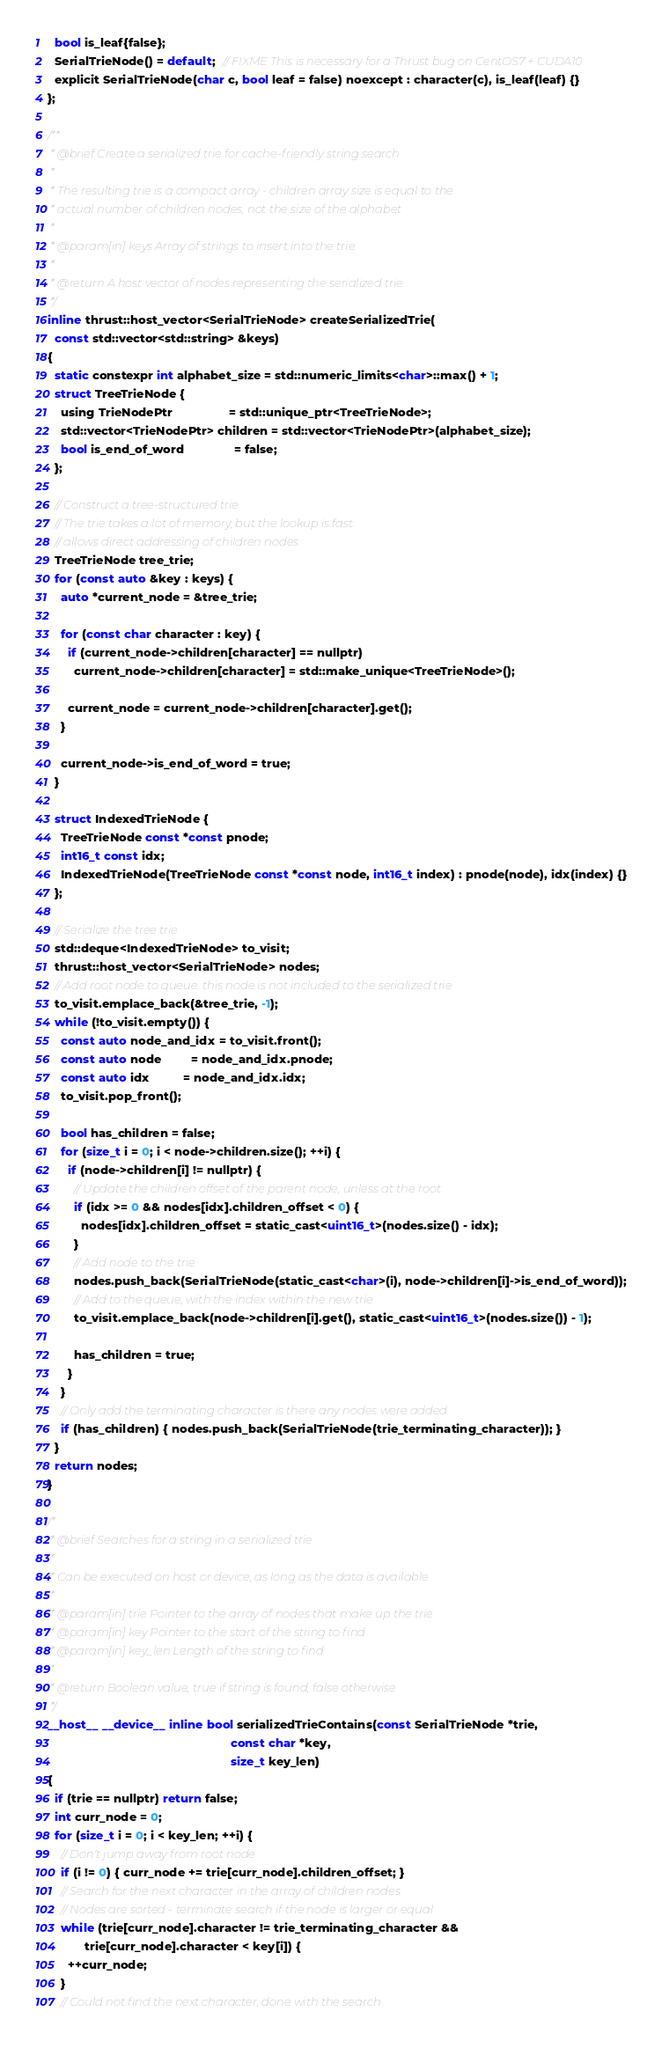<code> <loc_0><loc_0><loc_500><loc_500><_Cuda_>  bool is_leaf{false};
  SerialTrieNode() = default;  // FIXME This is necessary for a Thrust bug on CentOS7 + CUDA10
  explicit SerialTrieNode(char c, bool leaf = false) noexcept : character(c), is_leaf(leaf) {}
};

/**
 * @brief Create a serialized trie for cache-friendly string search
 *
 * The resulting trie is a compact array - children array size is equal to the
 * actual number of children nodes, not the size of the alphabet
 *
 * @param[in] keys Array of strings to insert into the trie
 *
 * @return A host vector of nodes representing the serialized trie
 */
inline thrust::host_vector<SerialTrieNode> createSerializedTrie(
  const std::vector<std::string> &keys)
{
  static constexpr int alphabet_size = std::numeric_limits<char>::max() + 1;
  struct TreeTrieNode {
    using TrieNodePtr                 = std::unique_ptr<TreeTrieNode>;
    std::vector<TrieNodePtr> children = std::vector<TrieNodePtr>(alphabet_size);
    bool is_end_of_word               = false;
  };

  // Construct a tree-structured trie
  // The trie takes a lot of memory, but the lookup is fast:
  // allows direct addressing of children nodes
  TreeTrieNode tree_trie;
  for (const auto &key : keys) {
    auto *current_node = &tree_trie;

    for (const char character : key) {
      if (current_node->children[character] == nullptr)
        current_node->children[character] = std::make_unique<TreeTrieNode>();

      current_node = current_node->children[character].get();
    }

    current_node->is_end_of_word = true;
  }

  struct IndexedTrieNode {
    TreeTrieNode const *const pnode;
    int16_t const idx;
    IndexedTrieNode(TreeTrieNode const *const node, int16_t index) : pnode(node), idx(index) {}
  };

  // Serialize the tree trie
  std::deque<IndexedTrieNode> to_visit;
  thrust::host_vector<SerialTrieNode> nodes;
  // Add root node to queue. this node is not included to the serialized trie
  to_visit.emplace_back(&tree_trie, -1);
  while (!to_visit.empty()) {
    const auto node_and_idx = to_visit.front();
    const auto node         = node_and_idx.pnode;
    const auto idx          = node_and_idx.idx;
    to_visit.pop_front();

    bool has_children = false;
    for (size_t i = 0; i < node->children.size(); ++i) {
      if (node->children[i] != nullptr) {
        // Update the children offset of the parent node, unless at the root
        if (idx >= 0 && nodes[idx].children_offset < 0) {
          nodes[idx].children_offset = static_cast<uint16_t>(nodes.size() - idx);
        }
        // Add node to the trie
        nodes.push_back(SerialTrieNode(static_cast<char>(i), node->children[i]->is_end_of_word));
        // Add to the queue, with the index within the new trie
        to_visit.emplace_back(node->children[i].get(), static_cast<uint16_t>(nodes.size()) - 1);

        has_children = true;
      }
    }
    // Only add the terminating character is there any nodes were added
    if (has_children) { nodes.push_back(SerialTrieNode(trie_terminating_character)); }
  }
  return nodes;
}

/*
 * @brief Searches for a string in a serialized trie
 *
 * Can be executed on host or device, as long as the data is available
 *
 * @param[in] trie Pointer to the array of nodes that make up the trie
 * @param[in] key Pointer to the start of the string to find
 * @param[in] key_len Length of the string to find
 *
 * @return Boolean value, true if string is found, false otherwise
 */
__host__ __device__ inline bool serializedTrieContains(const SerialTrieNode *trie,
                                                       const char *key,
                                                       size_t key_len)
{
  if (trie == nullptr) return false;
  int curr_node = 0;
  for (size_t i = 0; i < key_len; ++i) {
    // Don't jump away from root node
    if (i != 0) { curr_node += trie[curr_node].children_offset; }
    // Search for the next character in the array of children nodes
    // Nodes are sorted - terminate search if the node is larger or equal
    while (trie[curr_node].character != trie_terminating_character &&
           trie[curr_node].character < key[i]) {
      ++curr_node;
    }
    // Could not find the next character, done with the search</code> 